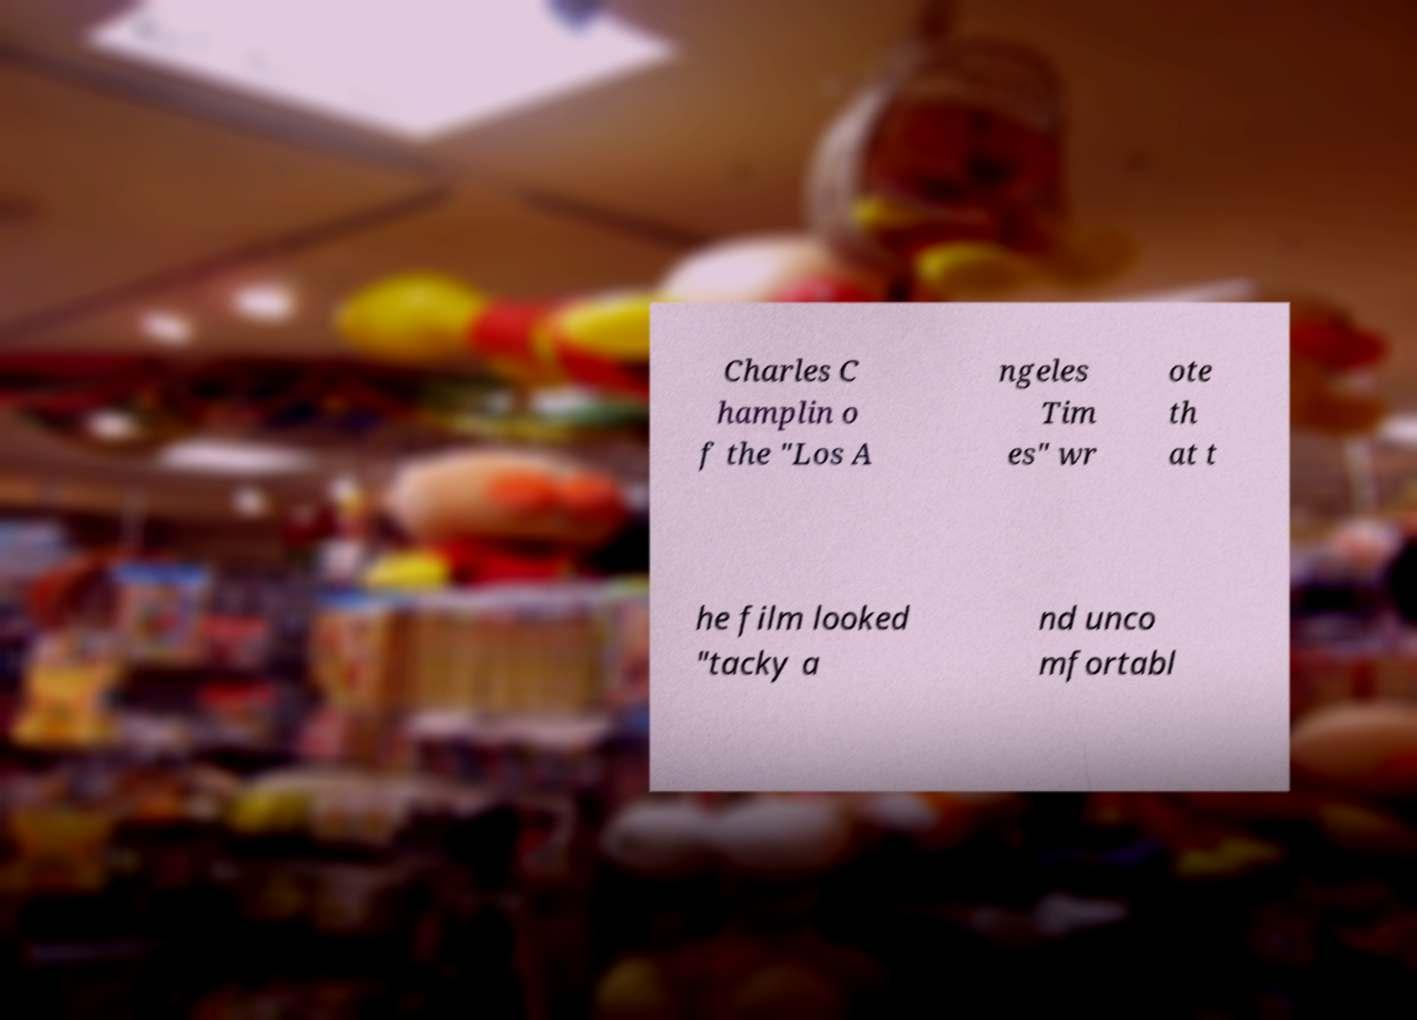Can you accurately transcribe the text from the provided image for me? Charles C hamplin o f the "Los A ngeles Tim es" wr ote th at t he film looked "tacky a nd unco mfortabl 